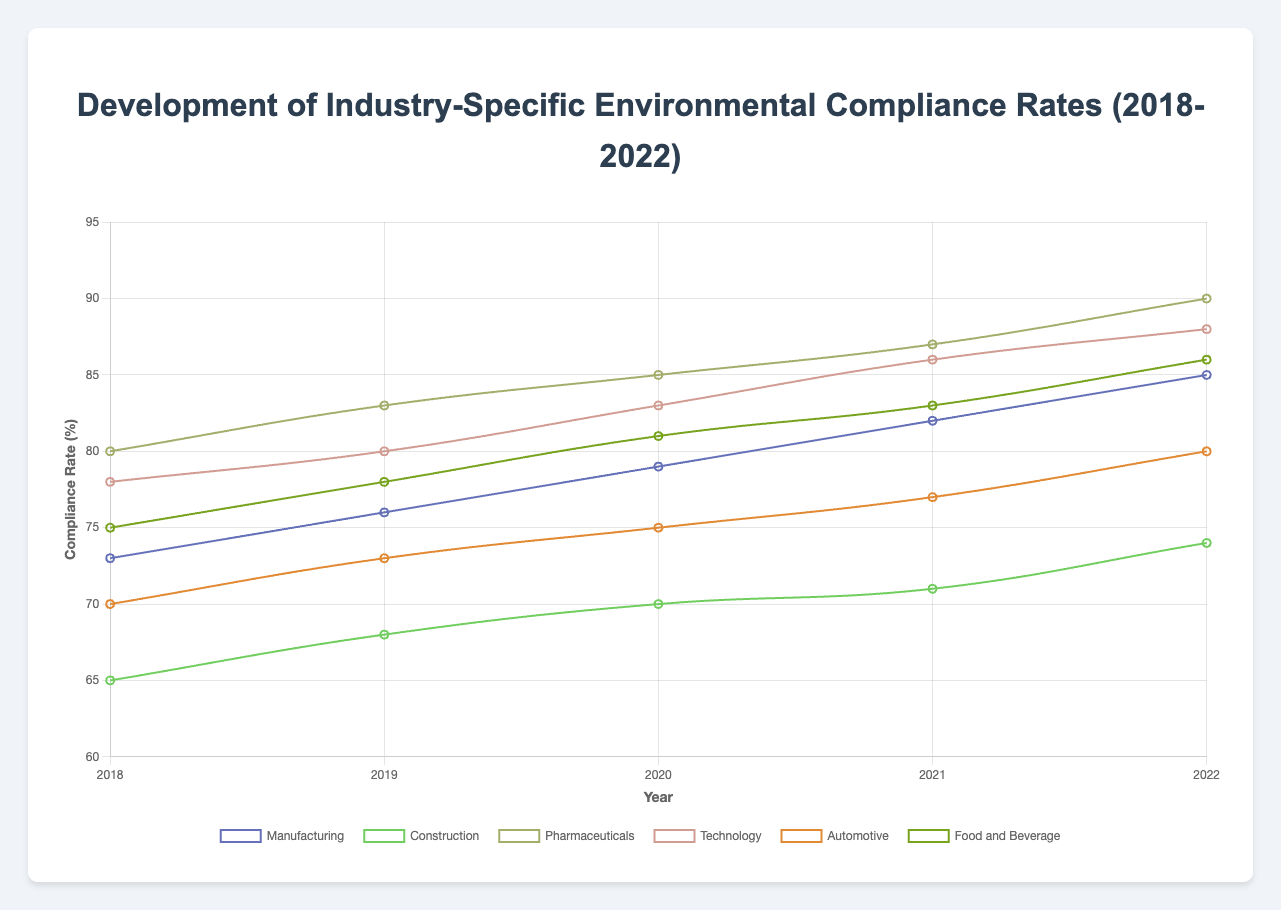Which industry had the highest compliance rate in 2022? In 2022, the Pharmaceuticals industry had a compliance rate of 90%, which is the highest among all industries.
Answer: Pharmaceuticals What was the average compliance rate of the Technology industry over the five years? The compliance rates for the Technology industry over the five years are 78, 80, 83, 86, and 88. Summing these values gives 415, and dividing by 5 gives an average of 83.
Answer: 83 Which industry showed the greatest improvement in compliance rate over the five years? To find the industry with the greatest improvement, subtract the 2018 compliance rate from the 2022 compliance rate for each industry. The Pharmaceuticals industry improved by 90 - 80 = 10, Technology by 88 - 78 = 10, Food and Beverage by 86 - 75 = 11, Automotive by 80 - 70 = 10, Construction by 74 - 65 = 9, and Manufacturing by 85 - 73 = 12. The Manufacturing industry showed the greatest improvement with a 12 percentage point increase.
Answer: Manufacturing Between 2018 and 2020, which industry had the lowest increase in compliance rates? To determine this, calculate the increase between 2018 and 2020 for each industry: Manufacturing increased by 79 - 73 = 6, Construction by 70 - 65 = 5, Pharmaceuticals by 85 - 80 = 5, Technology by 83 - 78 = 5, Automotive by 75 - 70 = 5, and Food and Beverage by 81 - 75 = 6. Construction, Pharmaceuticals, Technology, and Automotive all had the lowest increase of 5 percentage points.
Answer: Construction, Pharmaceuticals, Technology, Automotive What is the median compliance rate for the Automotive industry from 2018 to 2022? The compliance rates for the Automotive industry from 2018 to 2022 are 70, 73, 75, 77, and 80. Arranging these in ascending order, the median is the middle value, which is 75.
Answer: 75 Which two industries had the closest compliance rates in 2022? In 2022, the compliance rates are Manufacturing (85), Construction (74), Pharmaceuticals (90), Technology (88), Automotive (80), and Food and Beverage (86). The closest rates are Technology at 88 and Pharmaceuticals at 90, with a difference of 2 percentage points.
Answer: Technology and Pharmaceuticals How did the compliance rate for the Food and Beverage industry change from 2018 to 2021? The compliance rate for the Food and Beverage industry was 75 in 2018 and 83 in 2021. The change is 83 - 75 = 8 percentage points.
Answer: 8 percentage points 